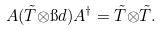Convert formula to latex. <formula><loc_0><loc_0><loc_500><loc_500>A ( \tilde { T } { \otimes } { \i d } ) A ^ { \dagger } = \tilde { T } { \otimes } \tilde { T } .</formula> 